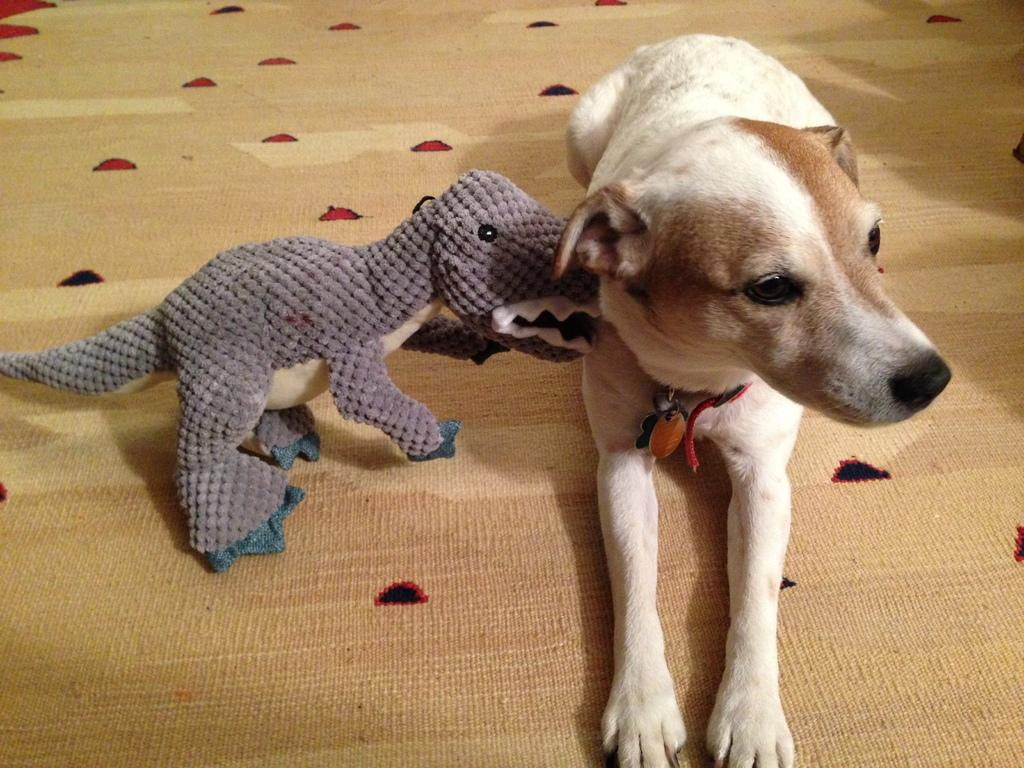What type of animal is in the image? There is a dog in the image. What position is the dog in? The dog is sitting on the floor. Where is the dog located in the image? The dog is in the center of the image. What other object can be seen on the floor in the image? There is a toy on the floor in the image. What type of cap is the dog wearing in the image? There is no cap present on the dog in the image. Can you see the dog's neck in the image? The image does not show the dog's neck specifically, but it does show the dog's head and body. Is there any poison visible in the image? There is no poison present in the image. 